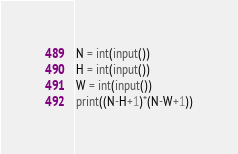Convert code to text. <code><loc_0><loc_0><loc_500><loc_500><_Python_>N = int(input())
H = int(input())
W = int(input())
print((N-H+1)*(N-W+1))
</code> 